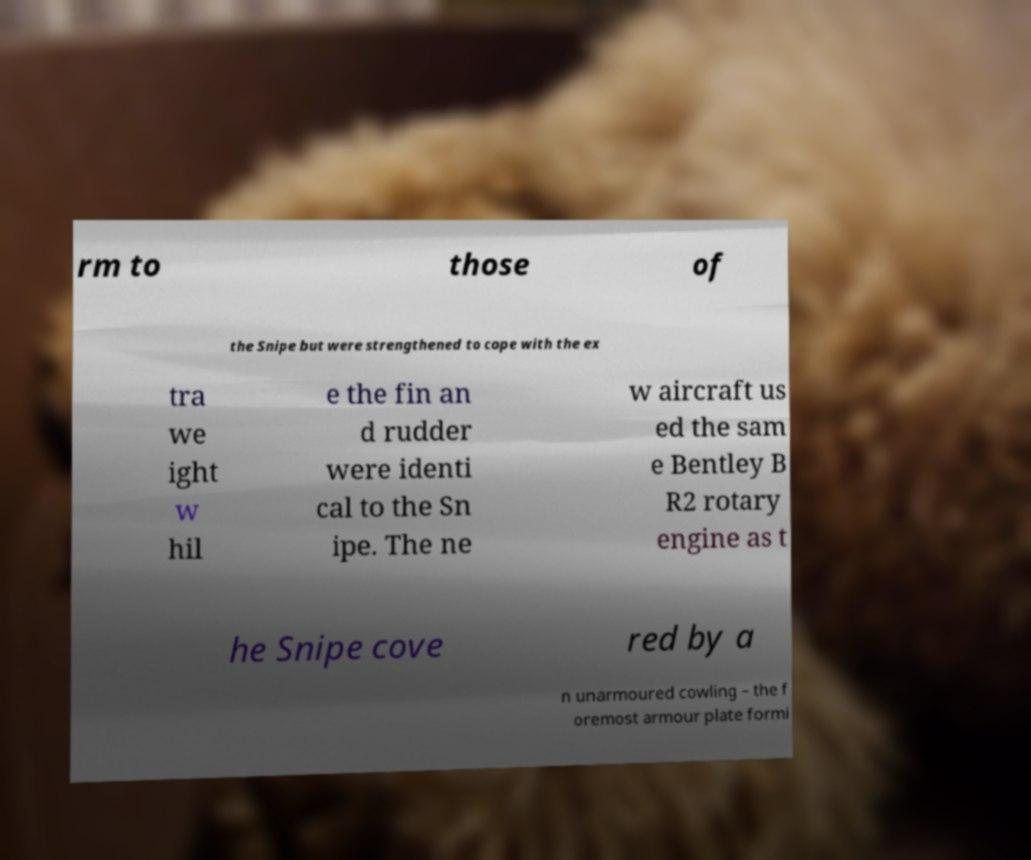There's text embedded in this image that I need extracted. Can you transcribe it verbatim? rm to those of the Snipe but were strengthened to cope with the ex tra we ight w hil e the fin an d rudder were identi cal to the Sn ipe. The ne w aircraft us ed the sam e Bentley B R2 rotary engine as t he Snipe cove red by a n unarmoured cowling – the f oremost armour plate formi 